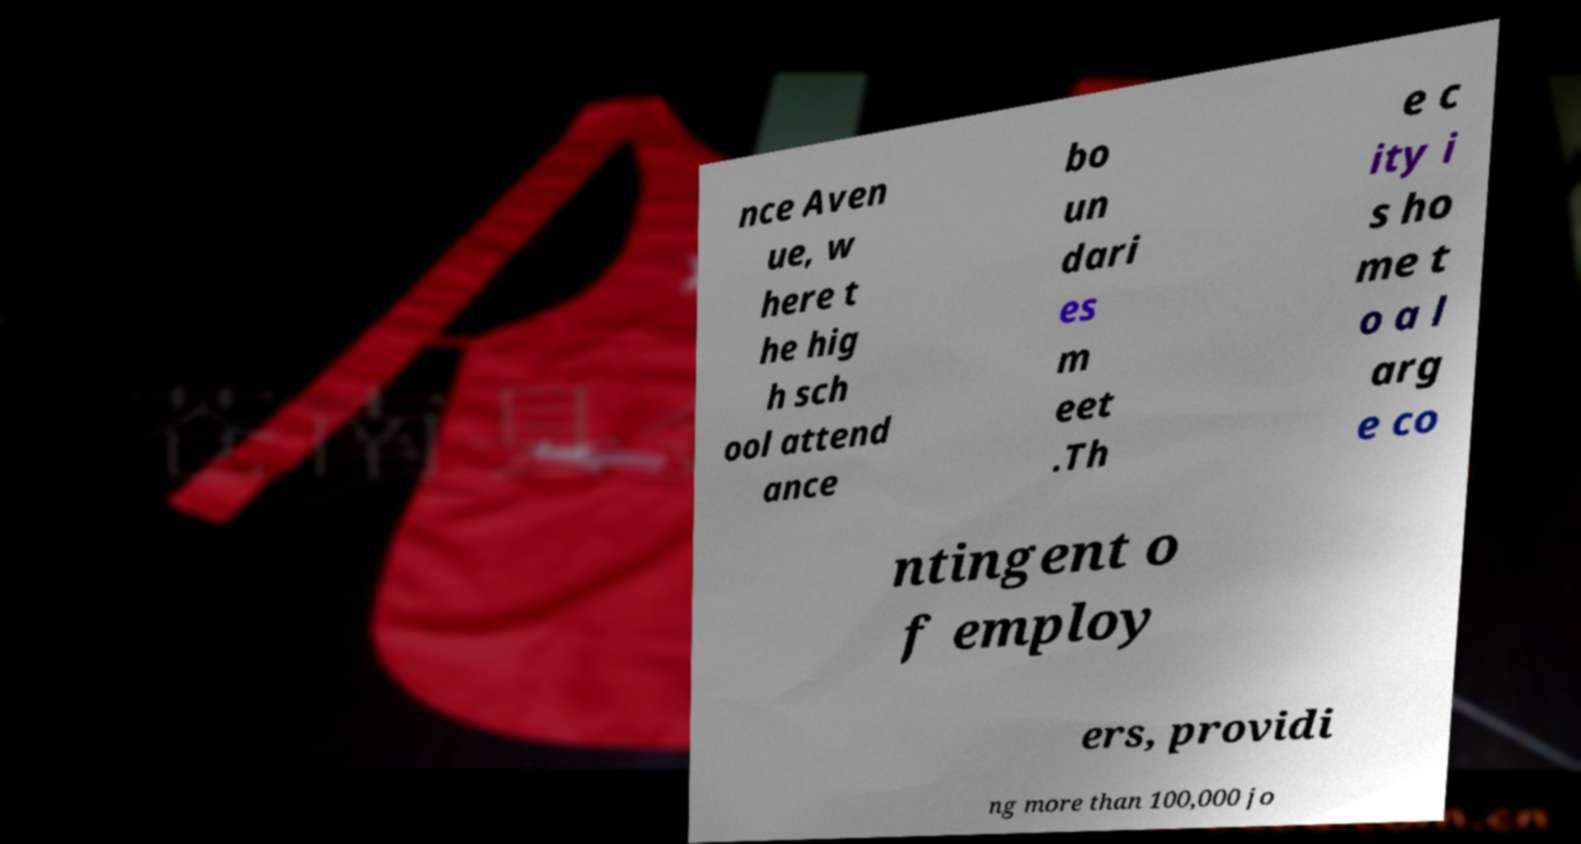For documentation purposes, I need the text within this image transcribed. Could you provide that? nce Aven ue, w here t he hig h sch ool attend ance bo un dari es m eet .Th e c ity i s ho me t o a l arg e co ntingent o f employ ers, providi ng more than 100,000 jo 